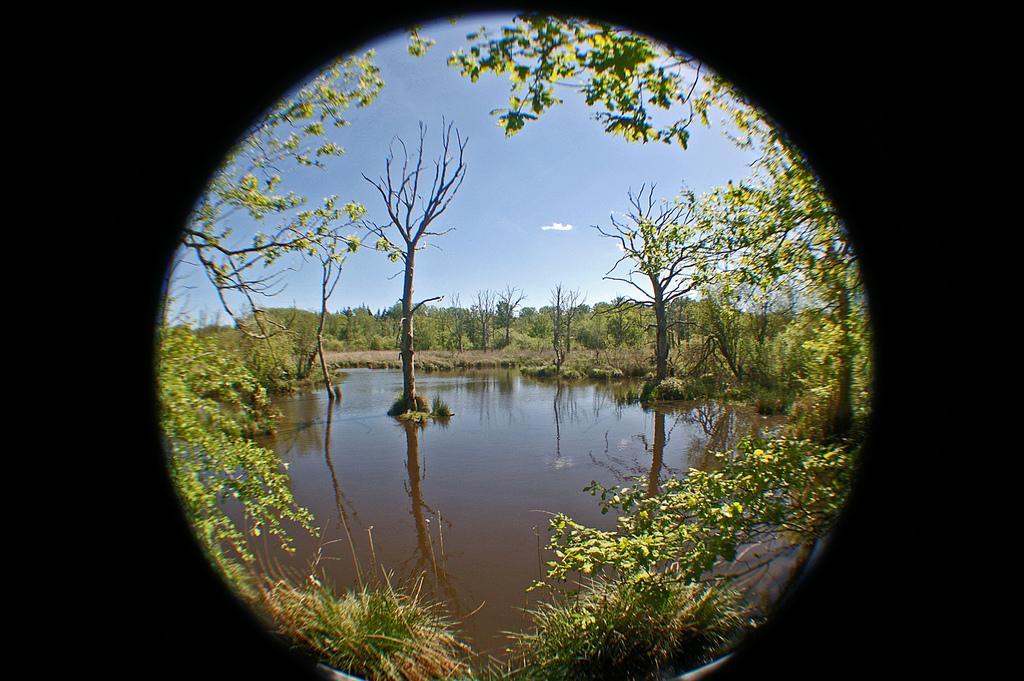In one or two sentences, can you explain what this image depicts? In the image in the center, we can see the sky, clouds, trees, plants and water. And we can see the black color, border around the image. 